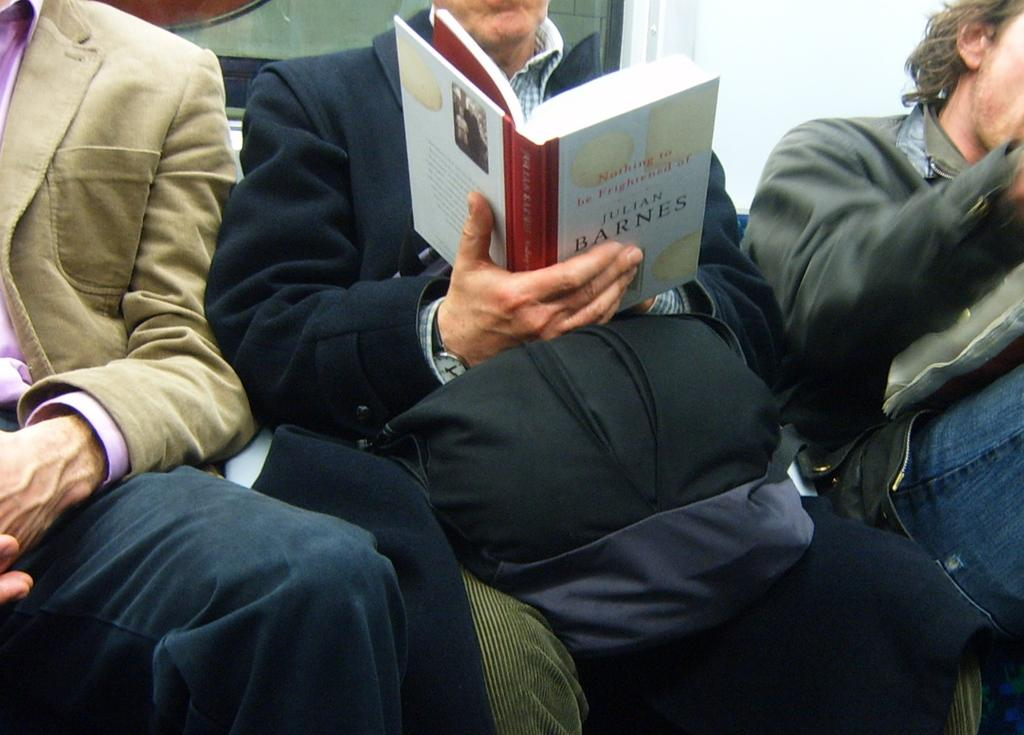Provide a one-sentence caption for the provided image. A man reads a book written by Julian Barnes. 